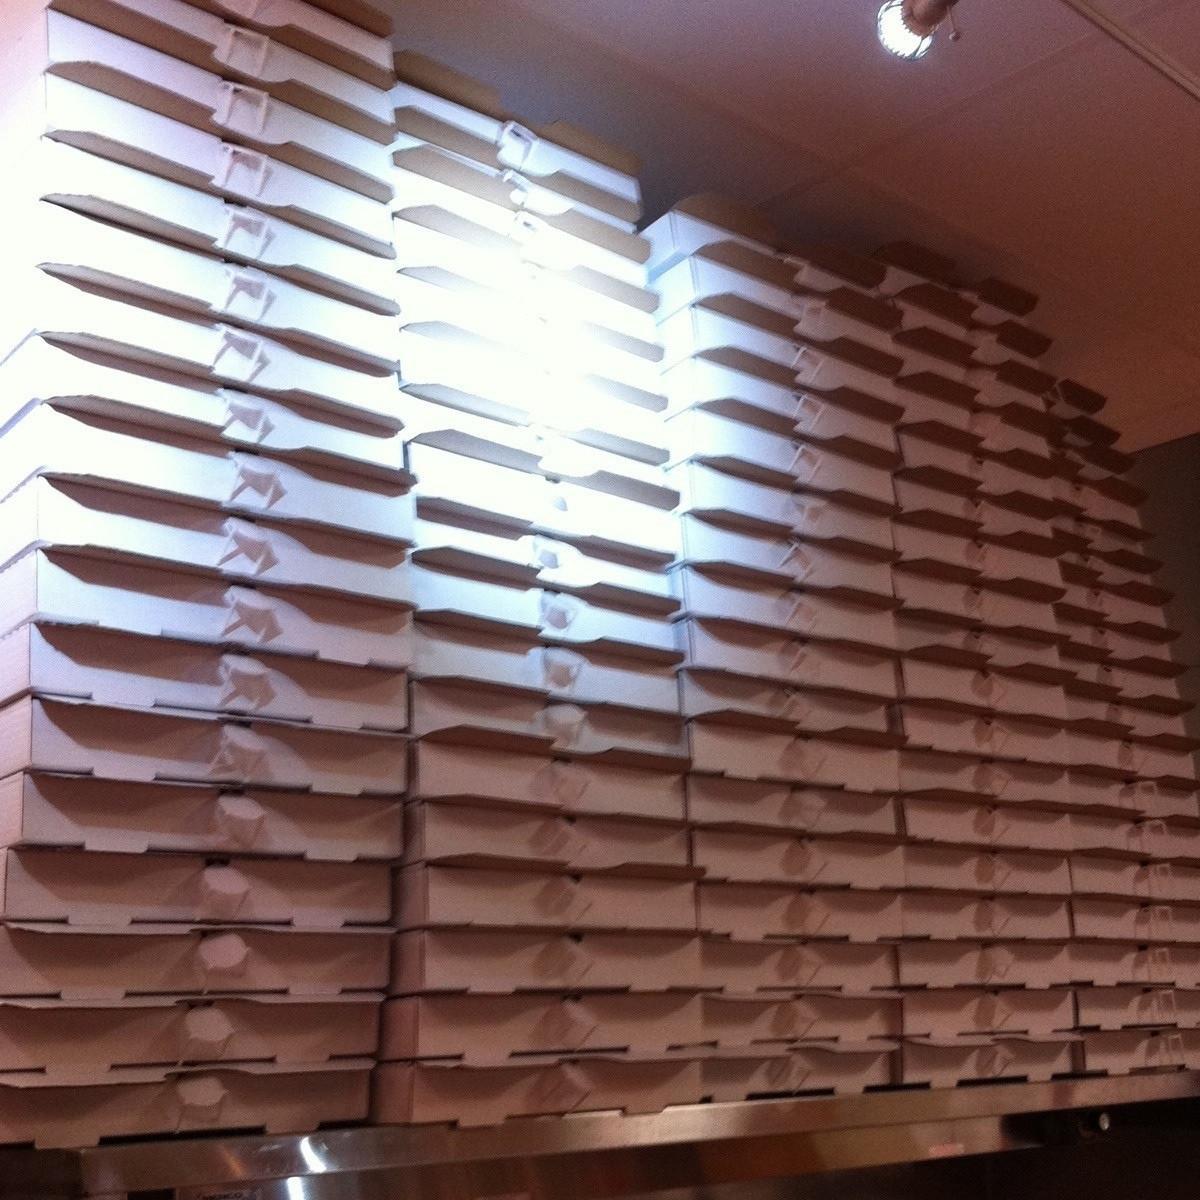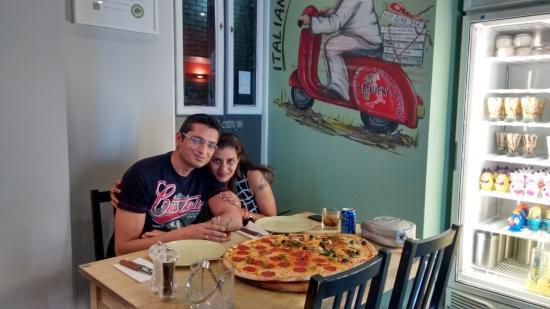The first image is the image on the left, the second image is the image on the right. For the images displayed, is the sentence "Both images contain pizza boxes." factually correct? Answer yes or no. No. 